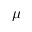<formula> <loc_0><loc_0><loc_500><loc_500>\mu</formula> 